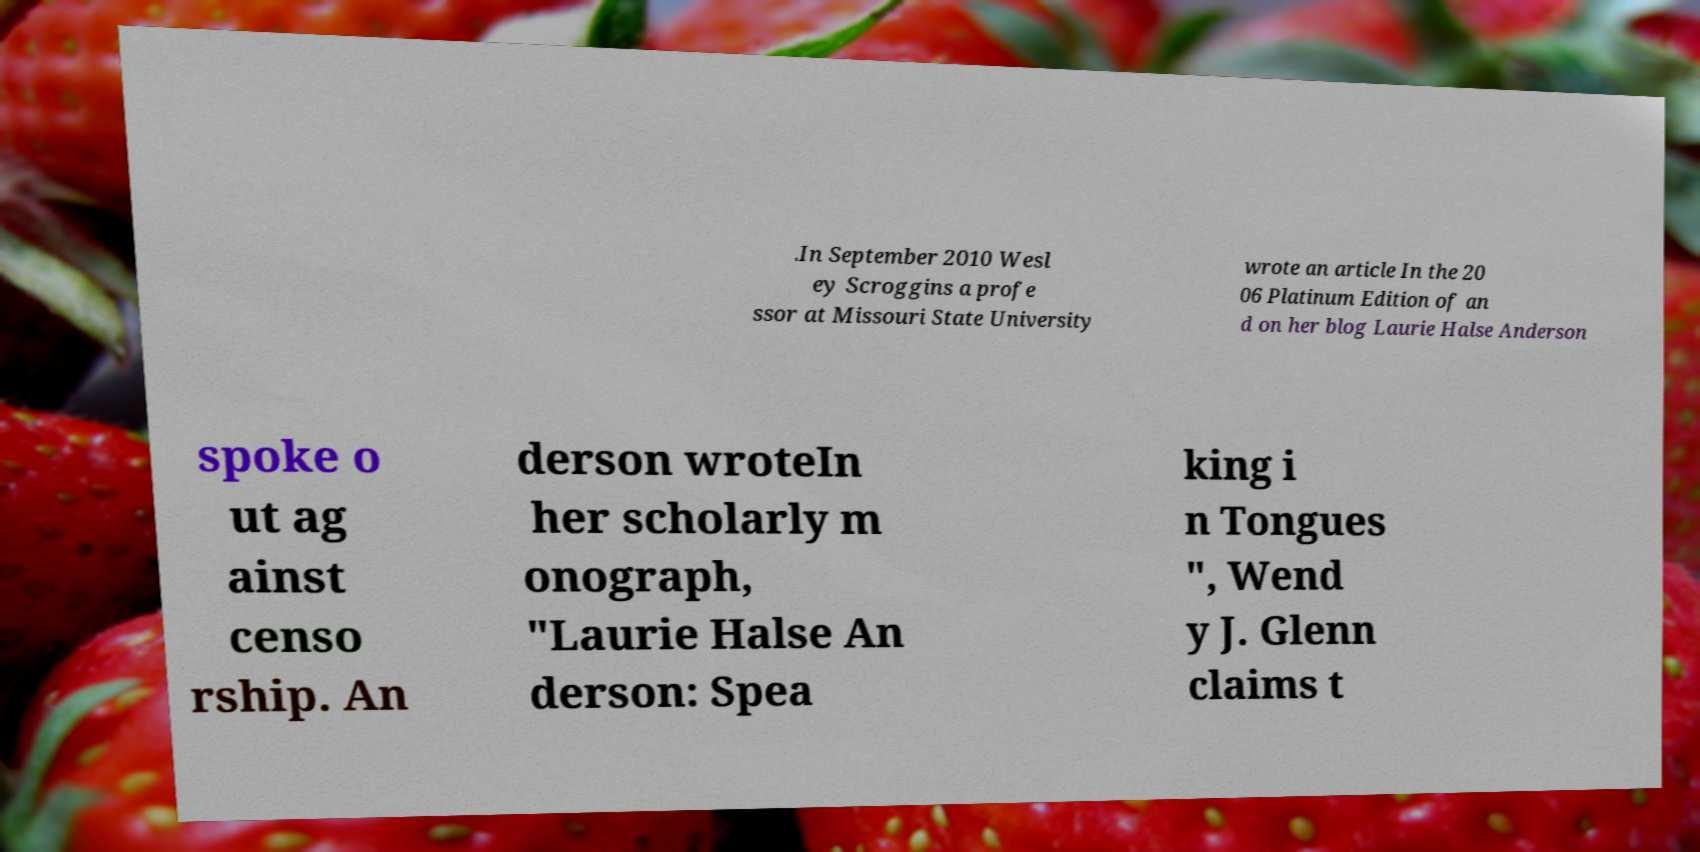Can you accurately transcribe the text from the provided image for me? .In September 2010 Wesl ey Scroggins a profe ssor at Missouri State University wrote an article In the 20 06 Platinum Edition of an d on her blog Laurie Halse Anderson spoke o ut ag ainst censo rship. An derson wroteIn her scholarly m onograph, "Laurie Halse An derson: Spea king i n Tongues ", Wend y J. Glenn claims t 